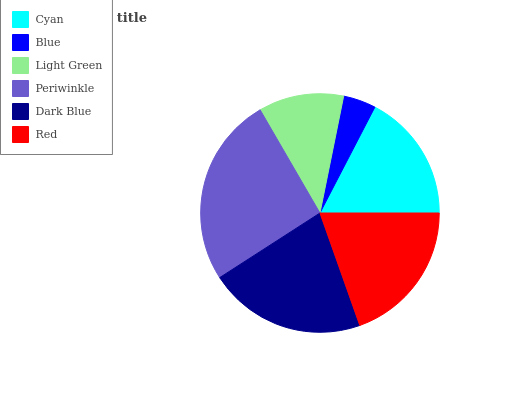Is Blue the minimum?
Answer yes or no. Yes. Is Periwinkle the maximum?
Answer yes or no. Yes. Is Light Green the minimum?
Answer yes or no. No. Is Light Green the maximum?
Answer yes or no. No. Is Light Green greater than Blue?
Answer yes or no. Yes. Is Blue less than Light Green?
Answer yes or no. Yes. Is Blue greater than Light Green?
Answer yes or no. No. Is Light Green less than Blue?
Answer yes or no. No. Is Red the high median?
Answer yes or no. Yes. Is Cyan the low median?
Answer yes or no. Yes. Is Cyan the high median?
Answer yes or no. No. Is Light Green the low median?
Answer yes or no. No. 